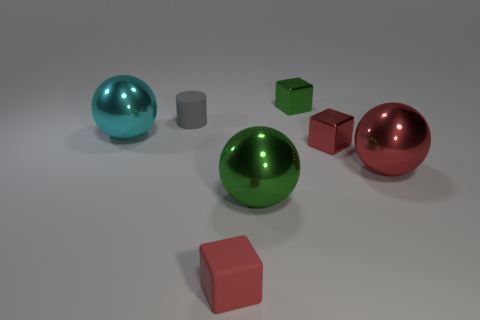Add 1 red metallic cylinders. How many objects exist? 8 Subtract all green cylinders. How many red cubes are left? 2 Subtract all metal blocks. How many blocks are left? 1 Subtract all cylinders. How many objects are left? 6 Subtract all cyan balls. How many balls are left? 2 Add 1 big spheres. How many big spheres exist? 4 Subtract 1 green blocks. How many objects are left? 6 Subtract all blue blocks. Subtract all yellow cylinders. How many blocks are left? 3 Subtract all small red matte objects. Subtract all gray matte objects. How many objects are left? 5 Add 7 green metal spheres. How many green metal spheres are left? 8 